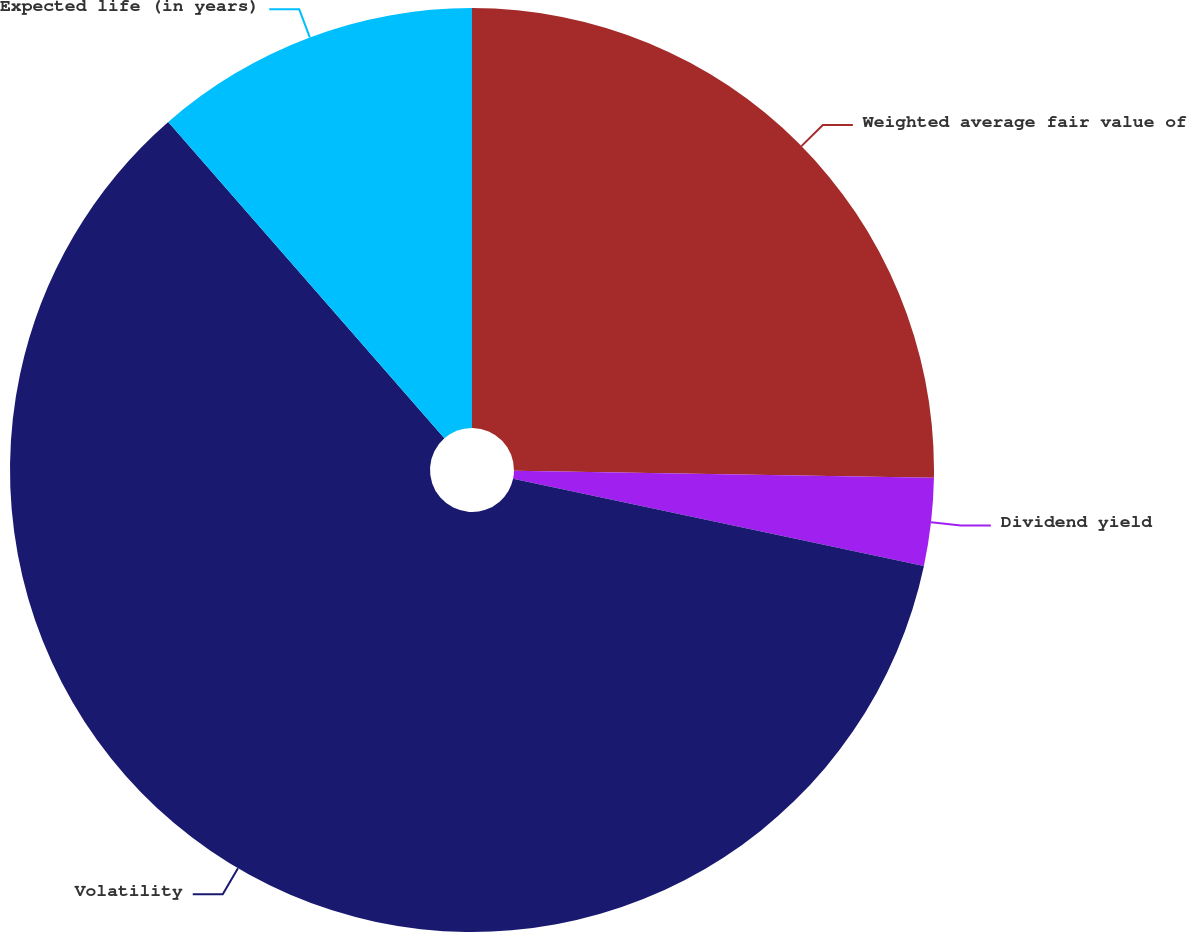Convert chart to OTSL. <chart><loc_0><loc_0><loc_500><loc_500><pie_chart><fcel>Weighted average fair value of<fcel>Dividend yield<fcel>Volatility<fcel>Expected life (in years)<nl><fcel>25.27%<fcel>3.06%<fcel>60.25%<fcel>11.42%<nl></chart> 